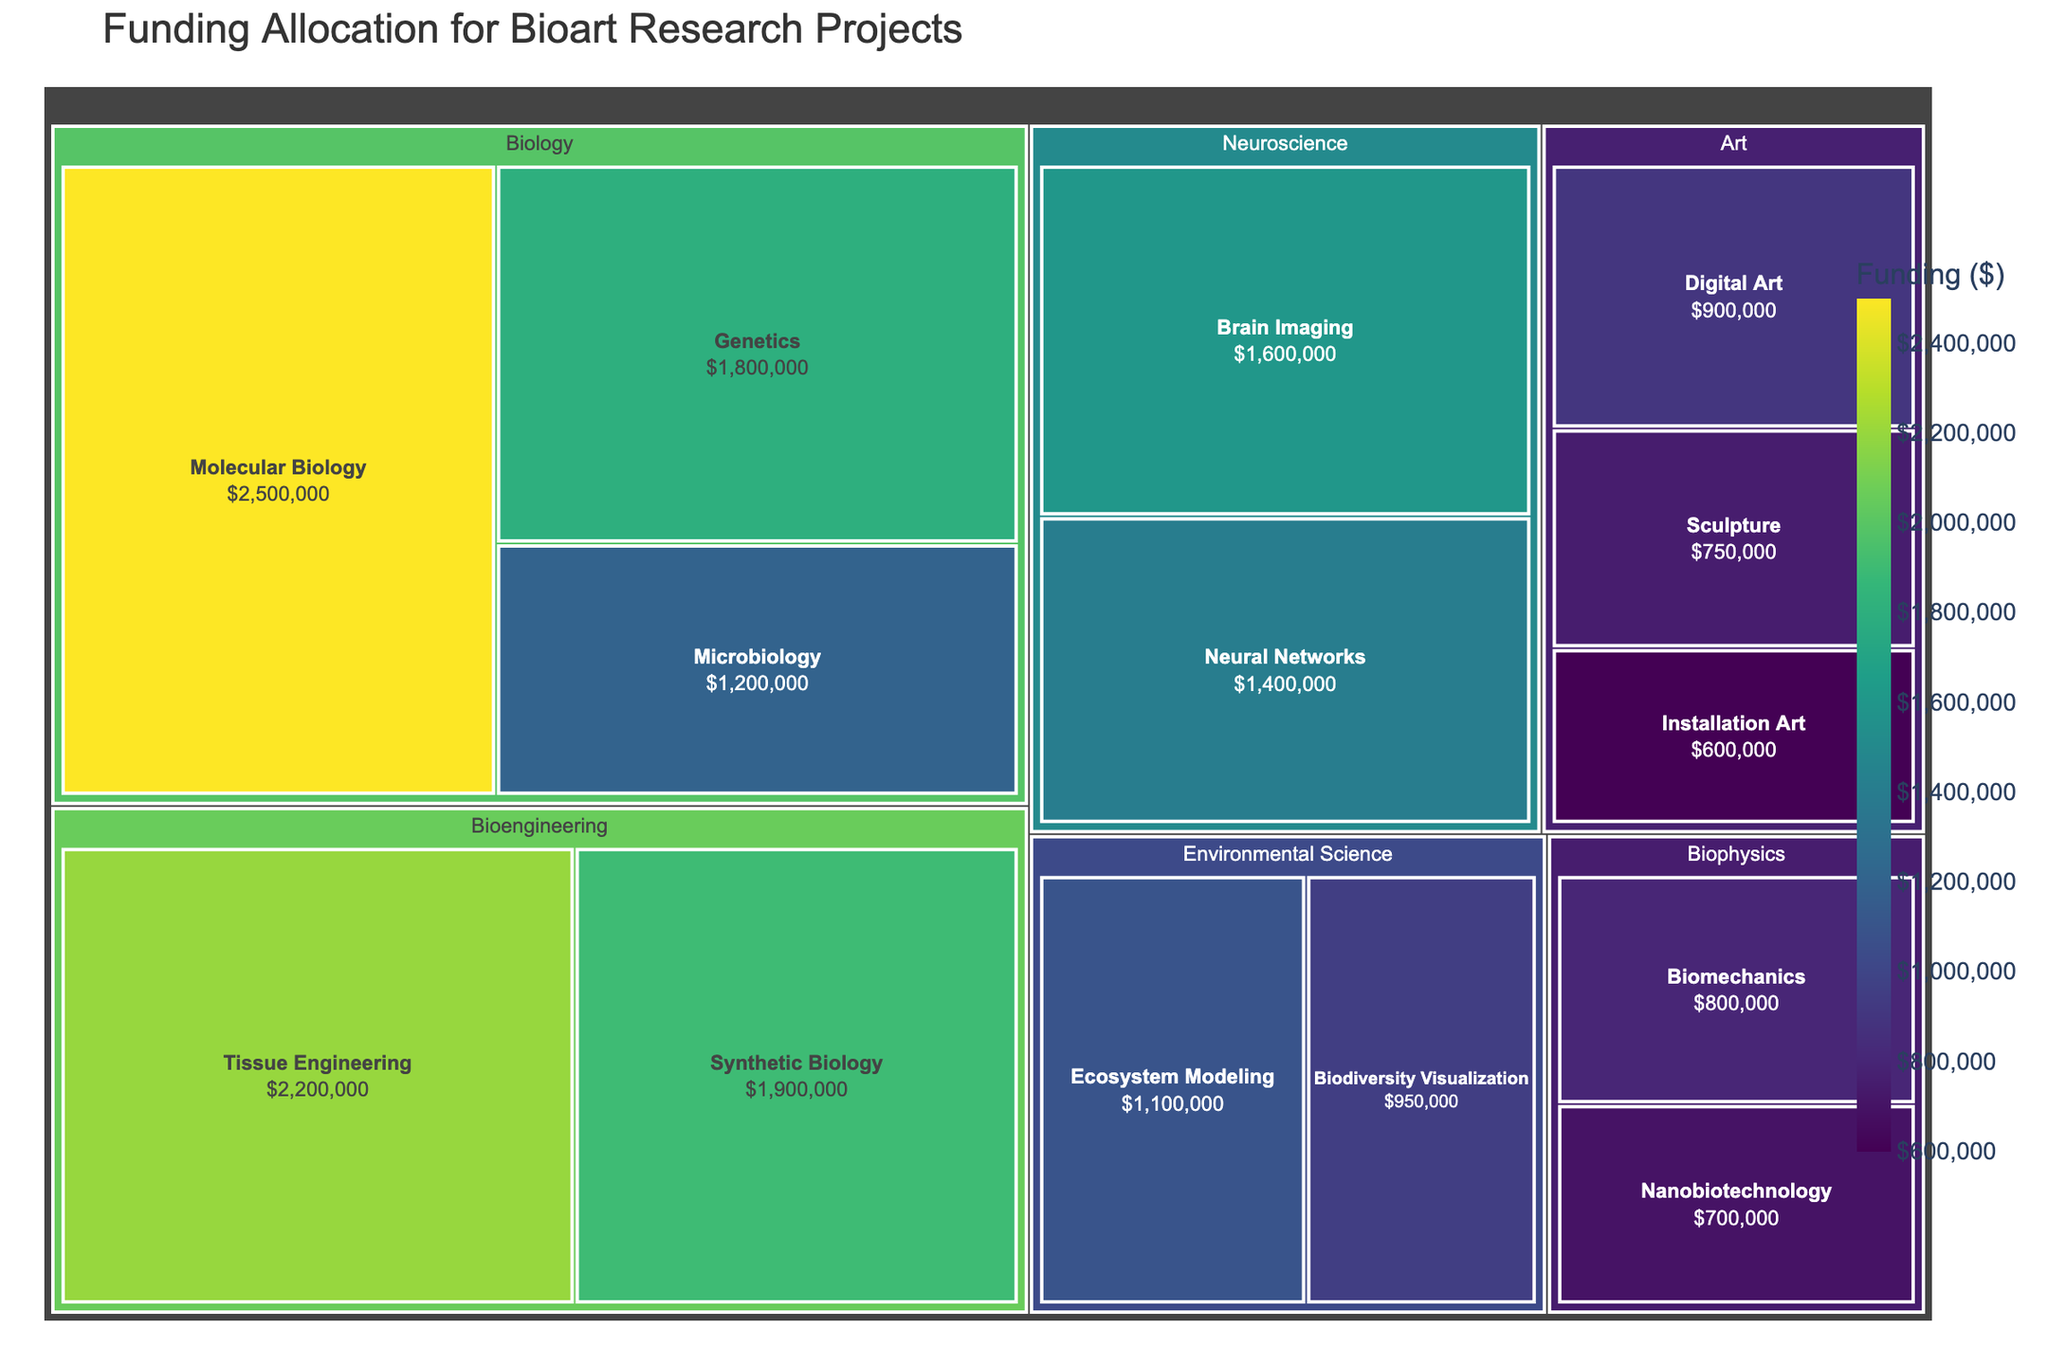What is the title of the treemap? The title of the treemap is displayed at the top of the figure, usually in a larger and bolder font compared to other text elements. It provides a summary of what the figure represents.
Answer: Funding Allocation for Bioart Research Projects Which subfield in Biology received the highest funding? From the treemap, you can identify the largest colored tile within the Biology category, as it represents the subfield with the highest funding allocation in this field.
Answer: Molecular Biology How much total funding was allocated to Art-related research projects? Sum the funding amounts for each subfield under the Art category: Digital Art ($900,000) + Sculpture ($750,000) + Installation Art ($600,000).
Answer: $2,250,000 Is the funding for Tissue Engineering greater than or equal to the funding for Genetic and Neural Networks combined? Compare the funding amount for Tissue Engineering ($2,200,000) with the sum of funding for Genetics ($1,800,000) and Neural Networks ($1,400,000), which totals $3,200,000.
Answer: No Which field has the smallest combined funding allocation and what is that amount? On the treemap, identify the field with the smallest total area occupied by its subfields. Add the funding amounts for the subfields within this field: Biophysics (Biomechanics $800,000 + Nanobiotechnology $700,000)
Answer: Biophysics, $1,500,000 What is the funding difference between Microbiology and Brain Imaging? Subtract the funding amount of Brain Imaging ($1,600,000) from that of Microbiology ($1,200,000).
Answer: $-400,000 Among the fields listed, which one received more funding: Biology or Bioengineering? Sum the funding amounts for the subfields within Biology and Bioengineering: Biology (Molecular Biology $2,500,000 + Genetics $1,800,000 + Microbiology $1,200,000) and Bioengineering (Tissue Engineering $2,200,000 + Synthetic Biology $1,900,000). Compare the two sums.
Answer: Biology Within Environmental Science, which subfield has the higher funding allocation? Compare the funding amounts of the two subfields within Environmental Science: Ecosystem Modeling ($1,100,000) and Biodiversity Visualization ($950,000).
Answer: Ecosystem Modeling Which subfield received the least funding overall? Locate the smallest tile in the treemap, which represents the subfield with the least funding allocation.
Answer: Nanobiotechnology How many subfields are there in total across all fields? Count all the tiles representing subfields in the treemap to determine the total number of subfields.
Answer: 14 